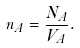<formula> <loc_0><loc_0><loc_500><loc_500>n _ { A } = \frac { N _ { A } } { V _ { A } } .</formula> 